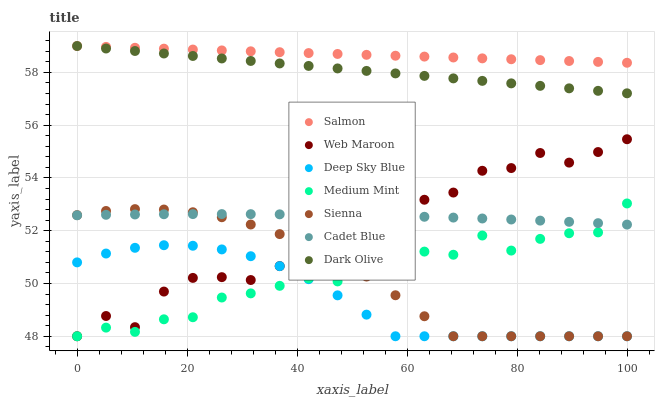Does Deep Sky Blue have the minimum area under the curve?
Answer yes or no. Yes. Does Salmon have the maximum area under the curve?
Answer yes or no. Yes. Does Cadet Blue have the minimum area under the curve?
Answer yes or no. No. Does Cadet Blue have the maximum area under the curve?
Answer yes or no. No. Is Dark Olive the smoothest?
Answer yes or no. Yes. Is Web Maroon the roughest?
Answer yes or no. Yes. Is Cadet Blue the smoothest?
Answer yes or no. No. Is Cadet Blue the roughest?
Answer yes or no. No. Does Medium Mint have the lowest value?
Answer yes or no. Yes. Does Cadet Blue have the lowest value?
Answer yes or no. No. Does Dark Olive have the highest value?
Answer yes or no. Yes. Does Cadet Blue have the highest value?
Answer yes or no. No. Is Cadet Blue less than Salmon?
Answer yes or no. Yes. Is Salmon greater than Medium Mint?
Answer yes or no. Yes. Does Web Maroon intersect Sienna?
Answer yes or no. Yes. Is Web Maroon less than Sienna?
Answer yes or no. No. Is Web Maroon greater than Sienna?
Answer yes or no. No. Does Cadet Blue intersect Salmon?
Answer yes or no. No. 